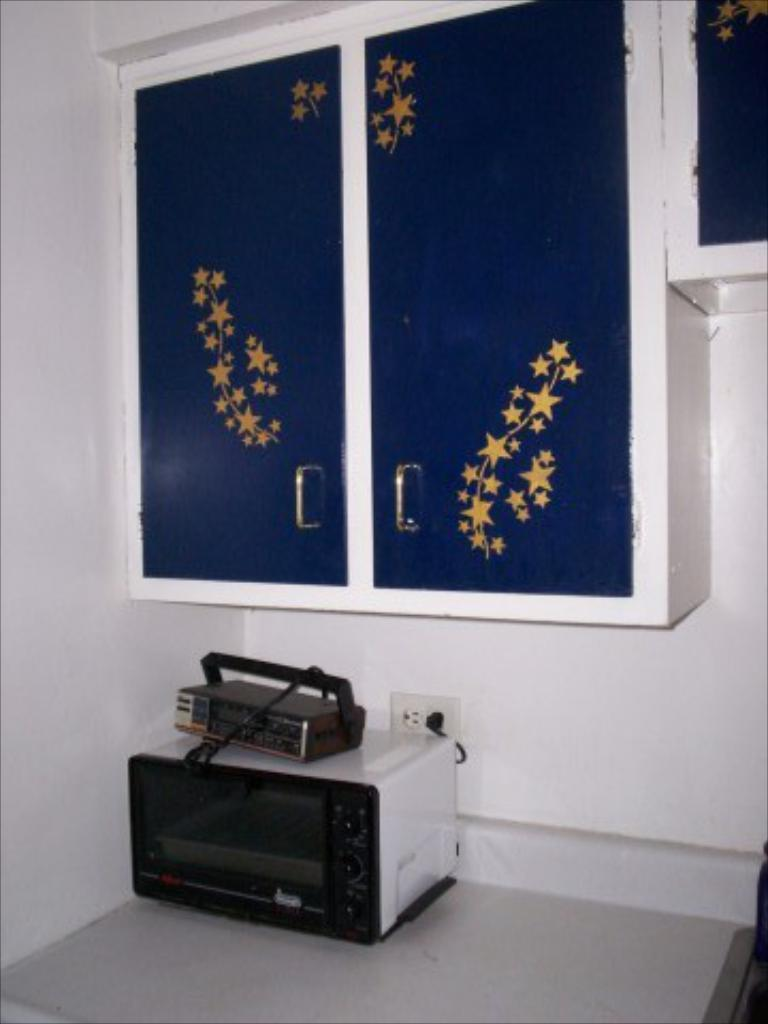What is located on the floor in the image? There is a device on the floor in the image. What can be seen on the wall in the background of the image? There are cupboards on the wall in the background of the image. What type of turkey is being cooked by the band in the image? There is no turkey or band present in the image. What number is associated with the device on the floor in the image? The facts provided do not mention any numbers associated with the device on the floor, so it cannot be determined from the image. 